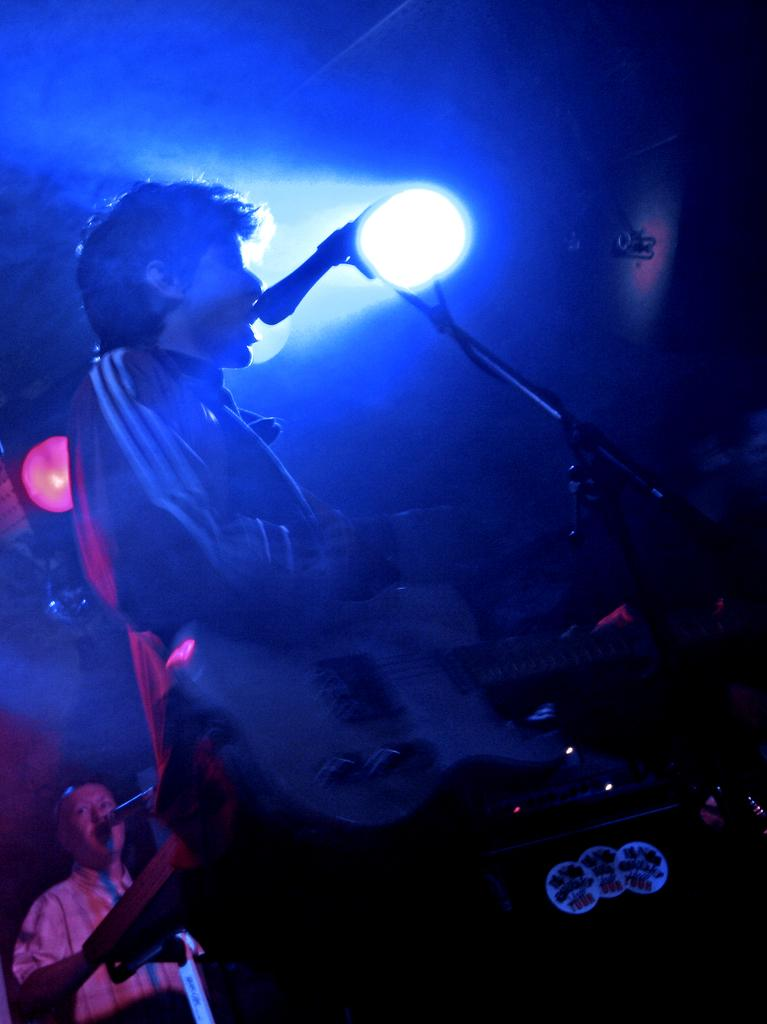What is the main subject of the image? There is a person in front of the mic. Are there any other people visible in the image? Yes, there is another person in the bottom left of the image. What can be seen in the middle of the image? There is a light in the middle of the image. How many children are playing on the land in the image? There are no children or land present in the image. 